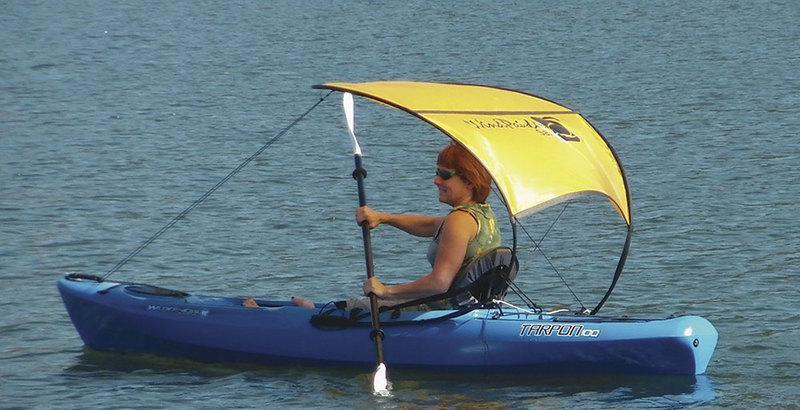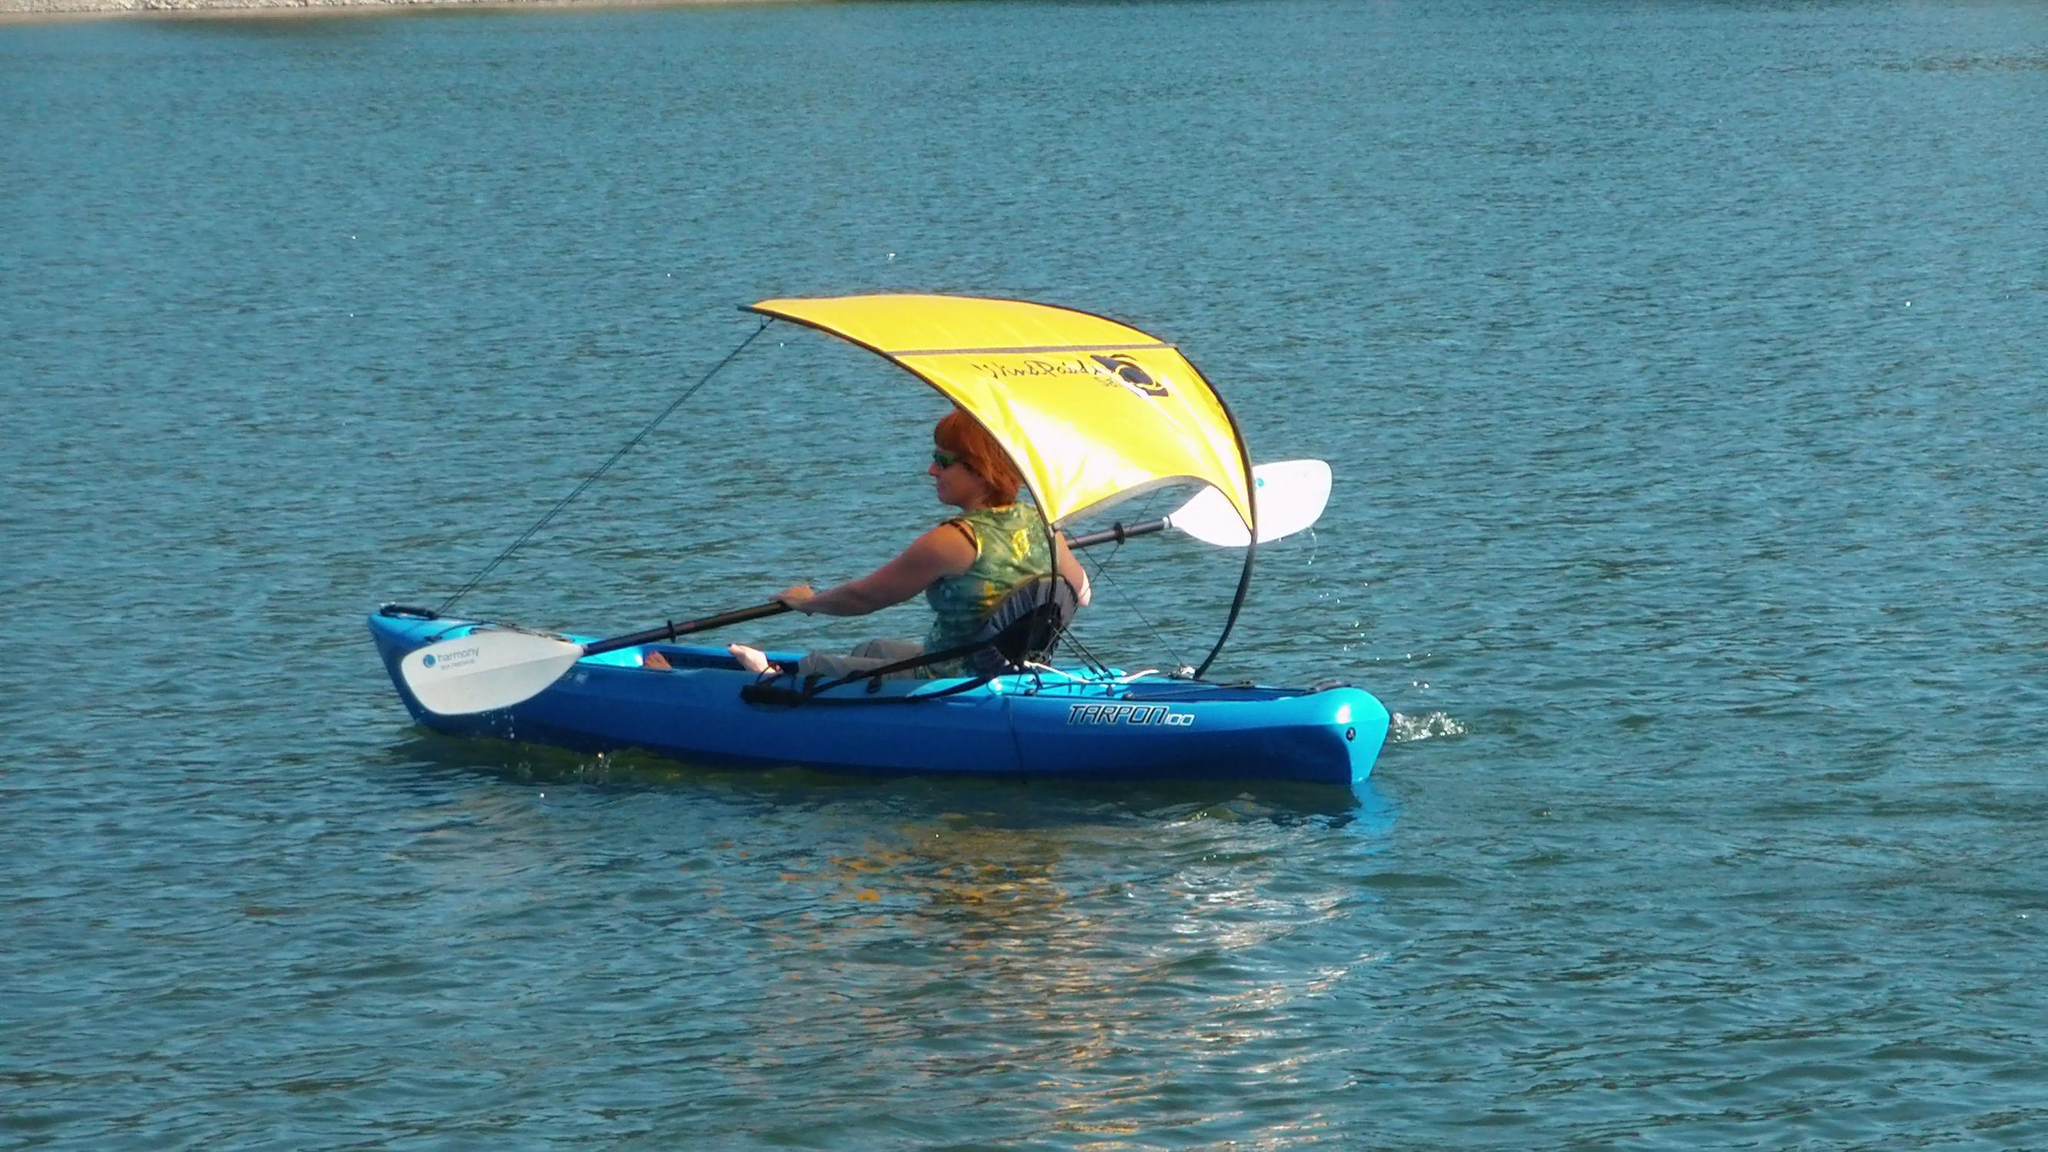The first image is the image on the left, the second image is the image on the right. Analyze the images presented: Is the assertion "There is a red canoe in water in the left image." valid? Answer yes or no. No. The first image is the image on the left, the second image is the image on the right. Given the left and right images, does the statement "There is a person in a canoe, on the water, facing right." hold true? Answer yes or no. No. 